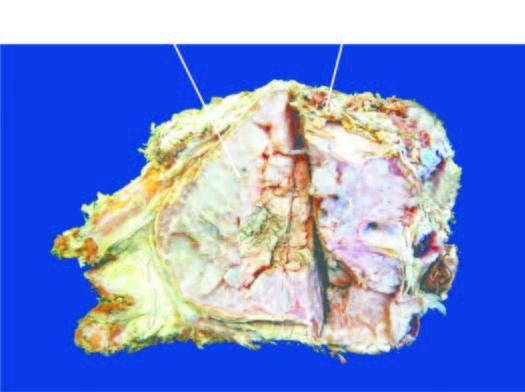s the basal layer expanded externally due to a gelatinous tumour?
Answer the question using a single word or phrase. No 